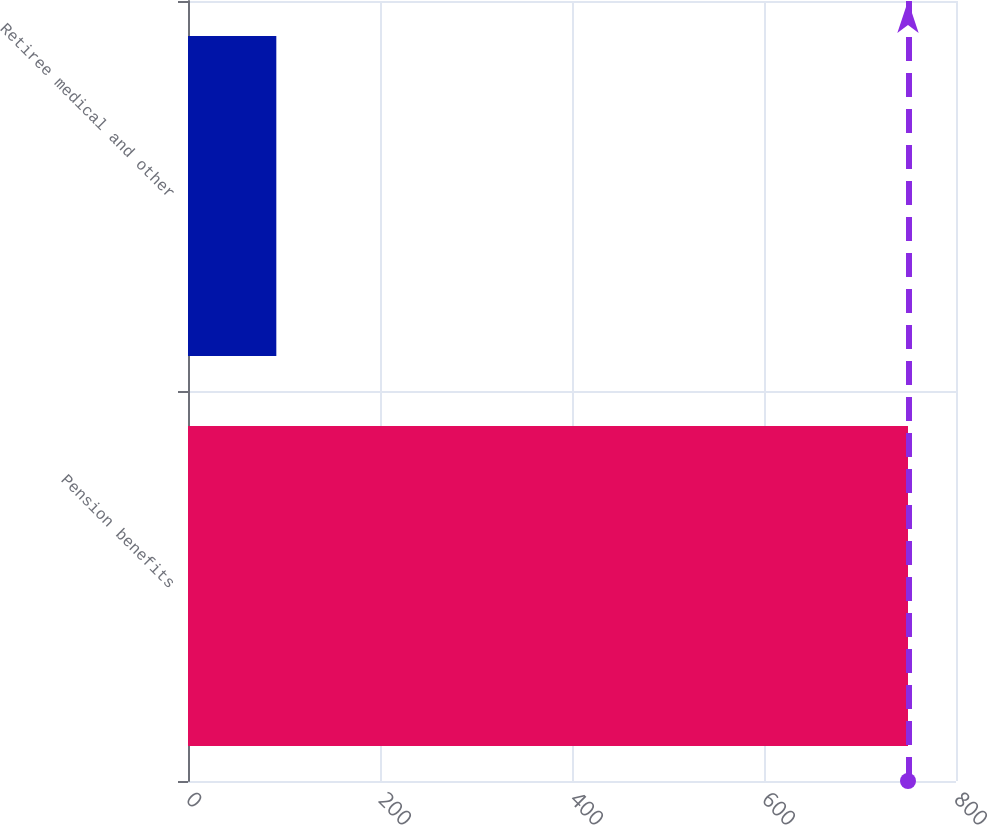Convert chart to OTSL. <chart><loc_0><loc_0><loc_500><loc_500><bar_chart><fcel>Pension benefits<fcel>Retiree medical and other<nl><fcel>750<fcel>92<nl></chart> 